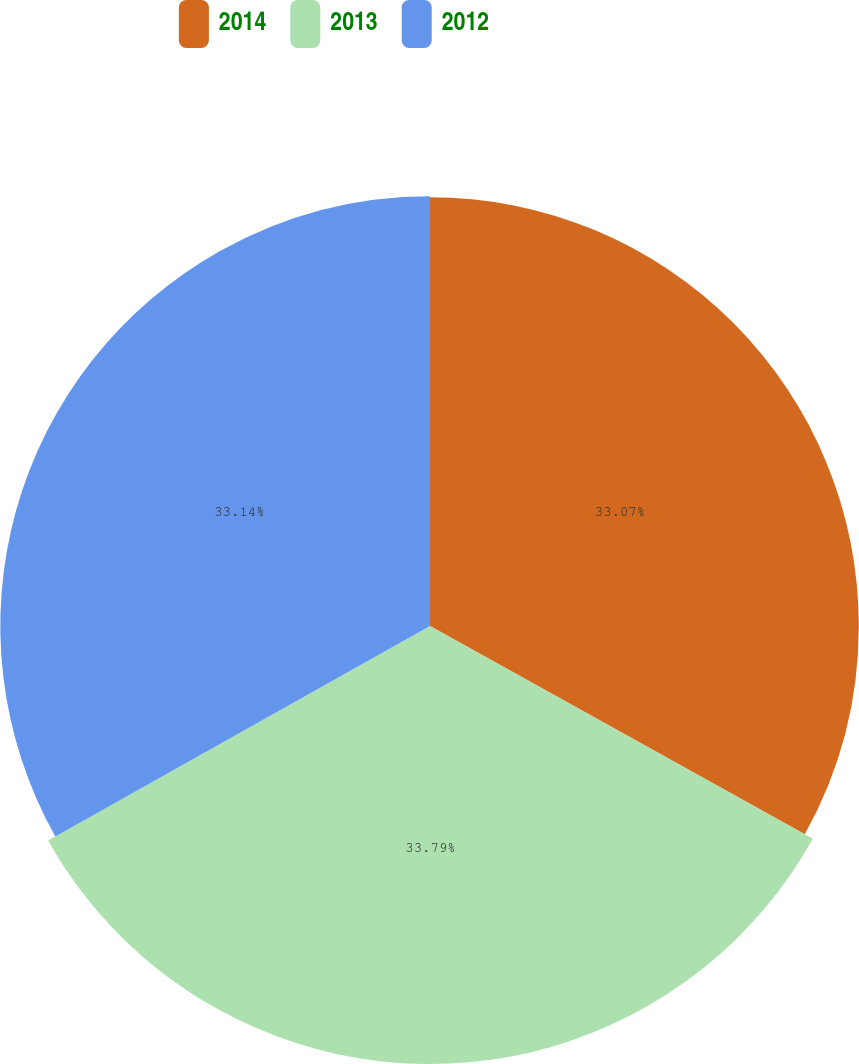Convert chart. <chart><loc_0><loc_0><loc_500><loc_500><pie_chart><fcel>2014<fcel>2013<fcel>2012<nl><fcel>33.07%<fcel>33.78%<fcel>33.14%<nl></chart> 